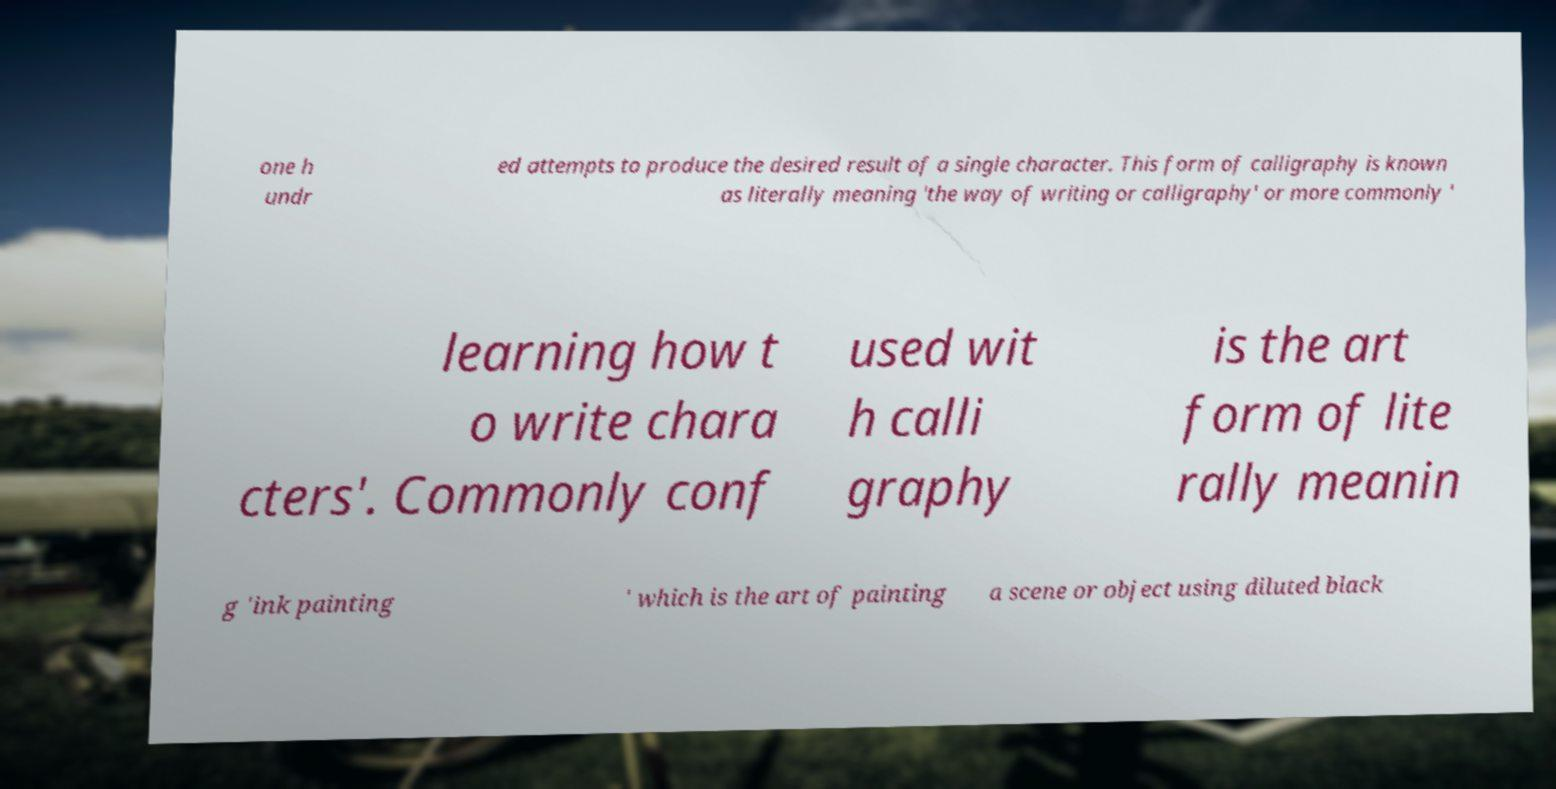Could you extract and type out the text from this image? one h undr ed attempts to produce the desired result of a single character. This form of calligraphy is known as literally meaning 'the way of writing or calligraphy' or more commonly ' learning how t o write chara cters'. Commonly conf used wit h calli graphy is the art form of lite rally meanin g 'ink painting ' which is the art of painting a scene or object using diluted black 